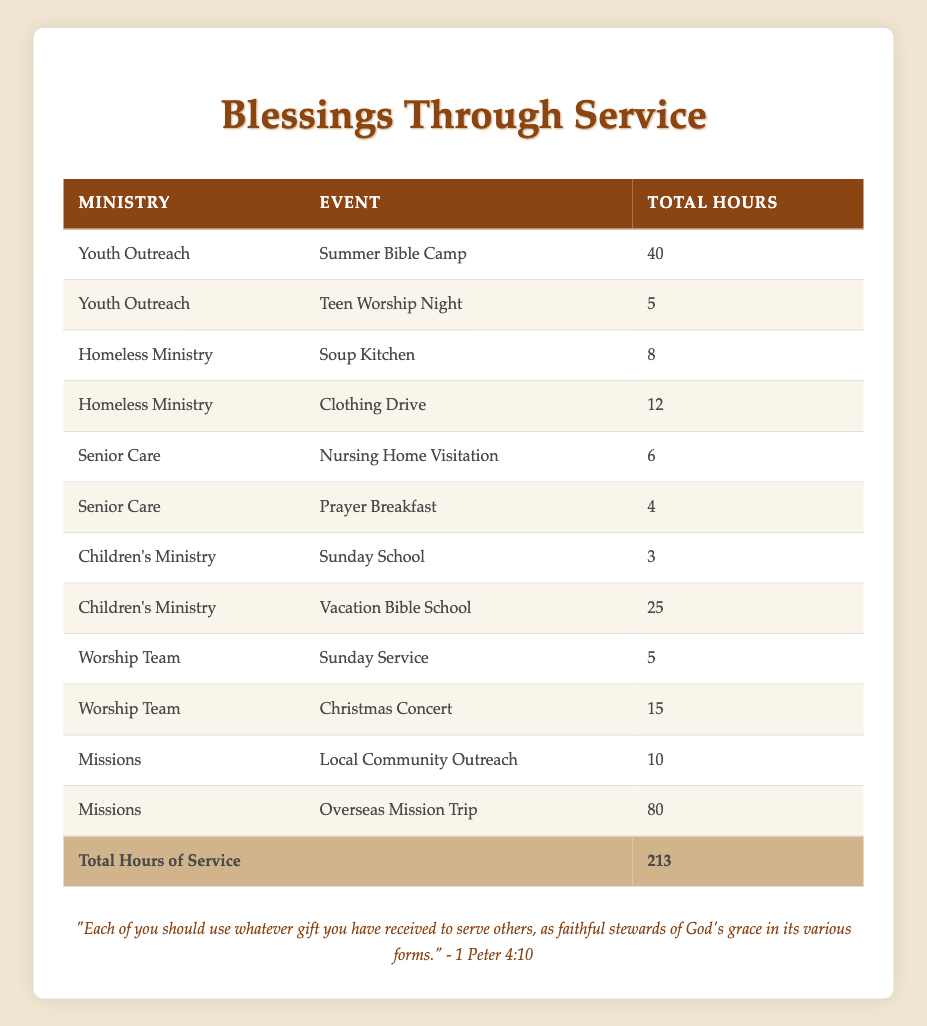What is the total number of volunteer hours contributed by the Youth Outreach ministry? The Youth Outreach ministry has two events listed: "Summer Bible Camp" with 40 hours and "Teen Worship Night" with 5 hours. Adding these together gives 40 + 5 = 45 hours.
Answer: 45 Which event under the Homeless Ministry had the least volunteer hours? The two events under the Homeless Ministry are "Soup Kitchen" with 8 hours and "Clothing Drive" with 12 hours. Comparing these, "Soup Kitchen" has the least at 8 hours.
Answer: Soup Kitchen Is the total number of volunteer hours for the Missions ministry greater than 80 hours? The Missions ministry has two events: "Local Community Outreach" with 10 hours and "Overseas Mission Trip" with 80 hours. The total is 10 + 80 = 90 hours, which is greater than 80.
Answer: Yes What is the average number of hours volunteered for events in the Senior Care ministry? In the Senior Care ministry, there are two events: "Nursing Home Visitation" with 6 hours and "Prayer Breakfast" with 4 hours. The total hours are 6 + 4 = 10, and since there are 2 events, the average is 10 / 2 = 5 hours.
Answer: 5 Which ministry contributed the highest total hours, and what is that amount? We need to calculate the total hours for each ministry: Youth Outreach has 45 hours, Homeless Ministry has 20 hours, Senior Care has 10 hours, Children's Ministry has 28 hours, Worship Team has 20 hours, and Missions has 90 hours. The highest is the Missions ministry with 90 hours.
Answer: Missions, 90 How many volunteers participated in the Children's Ministry events? The Children's Ministry has two events listed: "Sunday School" and "Vacation Bible School". Each event has one volunteer associated with it: Jennifer Lee for Sunday School and David Martinez for Vacation Bible School. Therefore, 2 volunteers participated.
Answer: 2 Is there any event in the Worship Team that had more than 10 hours of service? The Worship Team's events are "Sunday Service" with 5 hours and "Christmas Concert" with 15 hours. Since 15 hours is greater than 10, there is at least one event with more hours than that.
Answer: Yes What is the total volunteer hours contributed across all ministries listed? To find the total hours, we add together the hours from every ministry: 40 + 5 + 8 + 12 + 6 + 4 + 3 + 25 + 5 + 15 + 10 + 80 = 213 hours in total.
Answer: 213 Which individual contributed the most hours to a single event? Looking through the volunteer hours, John Smith contributed the most at the Summer Bible Camp with 40 hours, which is the highest single contribution among all events listed.
Answer: John Smith, 40 